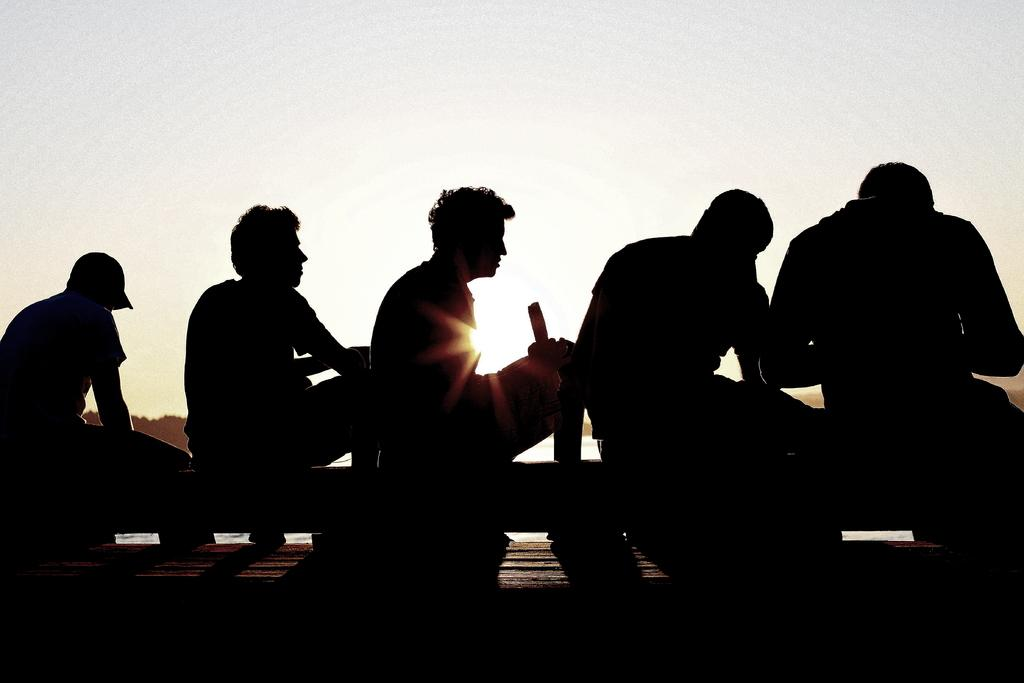How many people are in the image? There is a group of people in the image. What are the people in the image doing? The people are seated. What type of rifle is being used by the person in the image? There is no person holding a rifle in the image; the people are seated. What song is being sung by the group in the image? There is no indication of anyone singing in the image; the people are simply seated. 